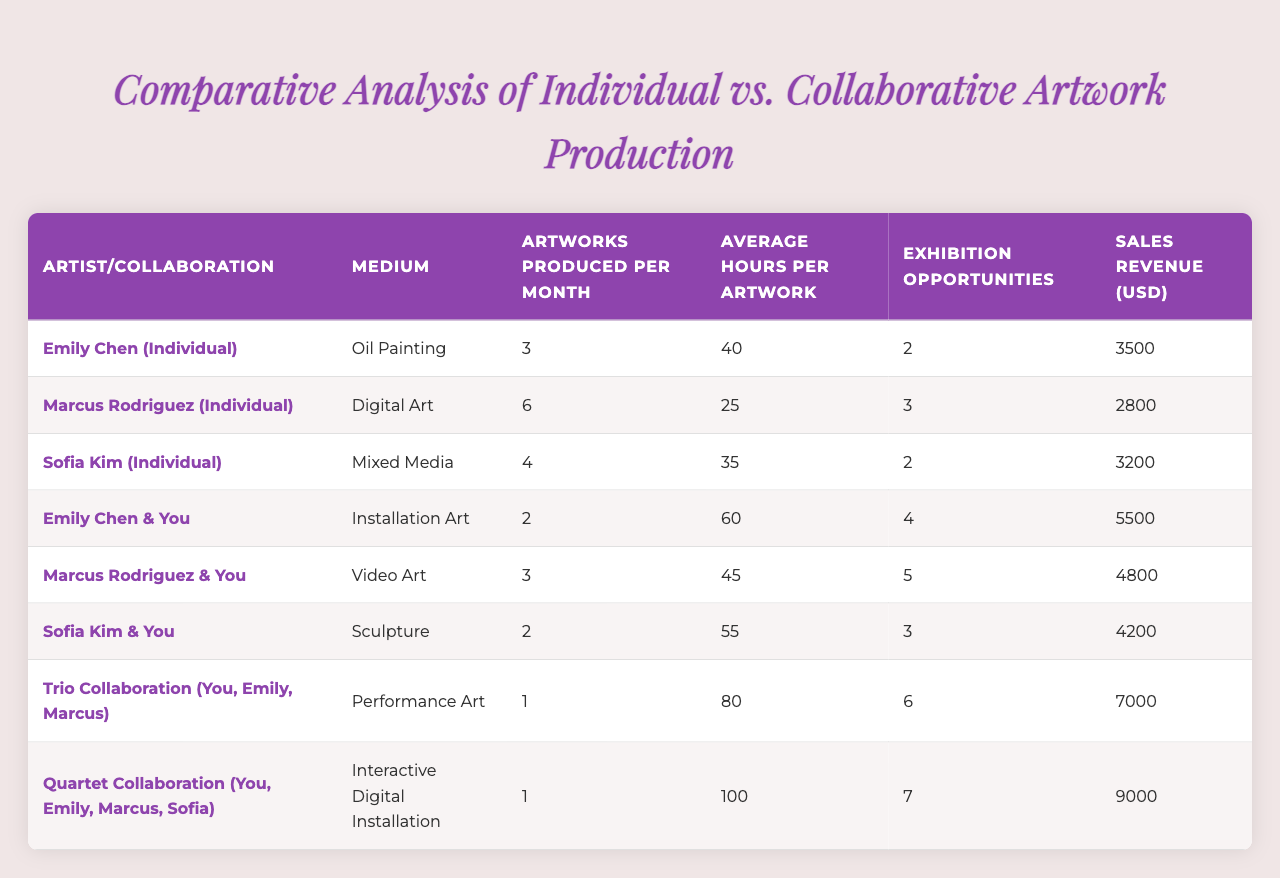What is the medium used by Emily Chen in her individual artwork? According to the table, the medium corresponding to Emily Chen (Individual) is listed as "Oil Painting."
Answer: Oil Painting How many artworks does Marcus Rodriguez produce per month? The table shows that Marcus Rodriguez (Individual) produces 6 artworks per month.
Answer: 6 Which collaboration type has the highest sales revenue? By comparing the sales revenue across all entries, the Quartet Collaboration (You, Emily, Marcus, Sofia) has the highest revenue at 9000 USD.
Answer: 9000 What is the average number of artworks produced per month by all the individual artists combined? The individual artists produced 3, 6, and 4 artworks respectively. The average is calculated as (3 + 6 + 4) / 3 = 13 / 3 ≈ 4.33.
Answer: 4.33 Which collaboration has the highest average hours spent per artwork? The average hours for each collaboration are examined, finding that the Quartet Collaboration has the highest at 100 hours.
Answer: 100 Is it true that Sofia Kim (Individual) has more exhibition opportunities than any collaborative project? Sofia Kim (Individual) has 2 exhibition opportunities, while the lowest collaborative project, Trio Collaboration, has 6 opportunities, meaning the statement is false.
Answer: False How much revenue is generated by collaborative projects on average? The revenues for collaborative projects are 5500, 4800, 7000, and 9000. Summing these gives 5500 + 4800 + 7000 + 9000 = 26300. The average is therefore 26300 / 4 = 6575.
Answer: 6575 What is the difference in artworks produced per month between individual and collaborative projects? The totals show individual projects produce 3+6+4=13 artworks monthly, while collaborative projects produce 2+3+2+1+1=9 monthly. The difference is 13 - 9 = 4 artworks.
Answer: 4 Which artist spends the most average hours per artwork when collaborating with you? The table reflects that in collaboration, you work with Sofia on Sculpture, which takes an average of 55 hours per artwork, while others vary, making this the highest.
Answer: 55 Do individual artists have a higher average sales revenue compared to collaborative projects? The total revenue for individual artists is (3500 + 2800 + 3200) = 9500 for 3 artists, resulting in an average of 9500 / 3 ≈ 3166.67. For collaborative projects, the total is (5500 + 4800 + 4200 + 7000 + 9000) = 30600 for 5 projects, leading to an average of 30600 / 5 = 6120. Thus, individual artists have lower revenue on average.
Answer: False 